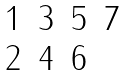<formula> <loc_0><loc_0><loc_500><loc_500>\begin{matrix} 1 & 3 & 5 & 7 \\ 2 & 4 & 6 & \\ \end{matrix}</formula> 